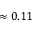Convert formula to latex. <formula><loc_0><loc_0><loc_500><loc_500>\approx 0 . 1 1</formula> 